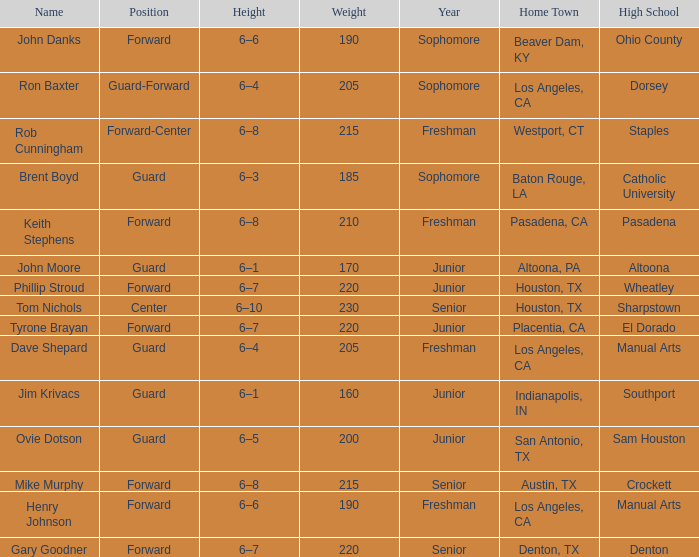What is the Name with a Year with freshman, and a Home Town with los angeles, ca, and a Height of 6–4? Dave Shepard. 